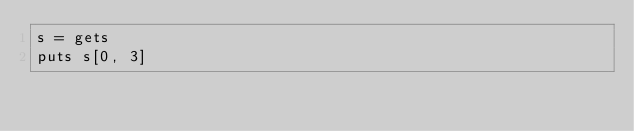Convert code to text. <code><loc_0><loc_0><loc_500><loc_500><_Ruby_>s = gets
puts s[0, 3]
</code> 